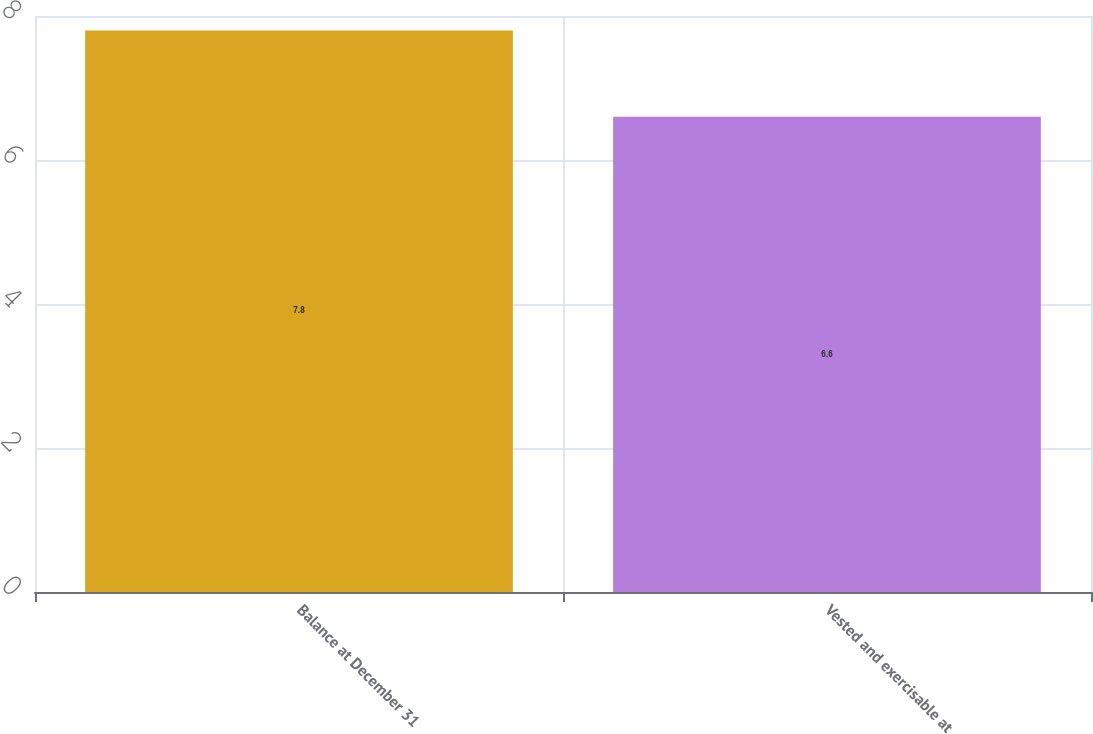Convert chart to OTSL. <chart><loc_0><loc_0><loc_500><loc_500><bar_chart><fcel>Balance at December 31<fcel>Vested and exercisable at<nl><fcel>7.8<fcel>6.6<nl></chart> 